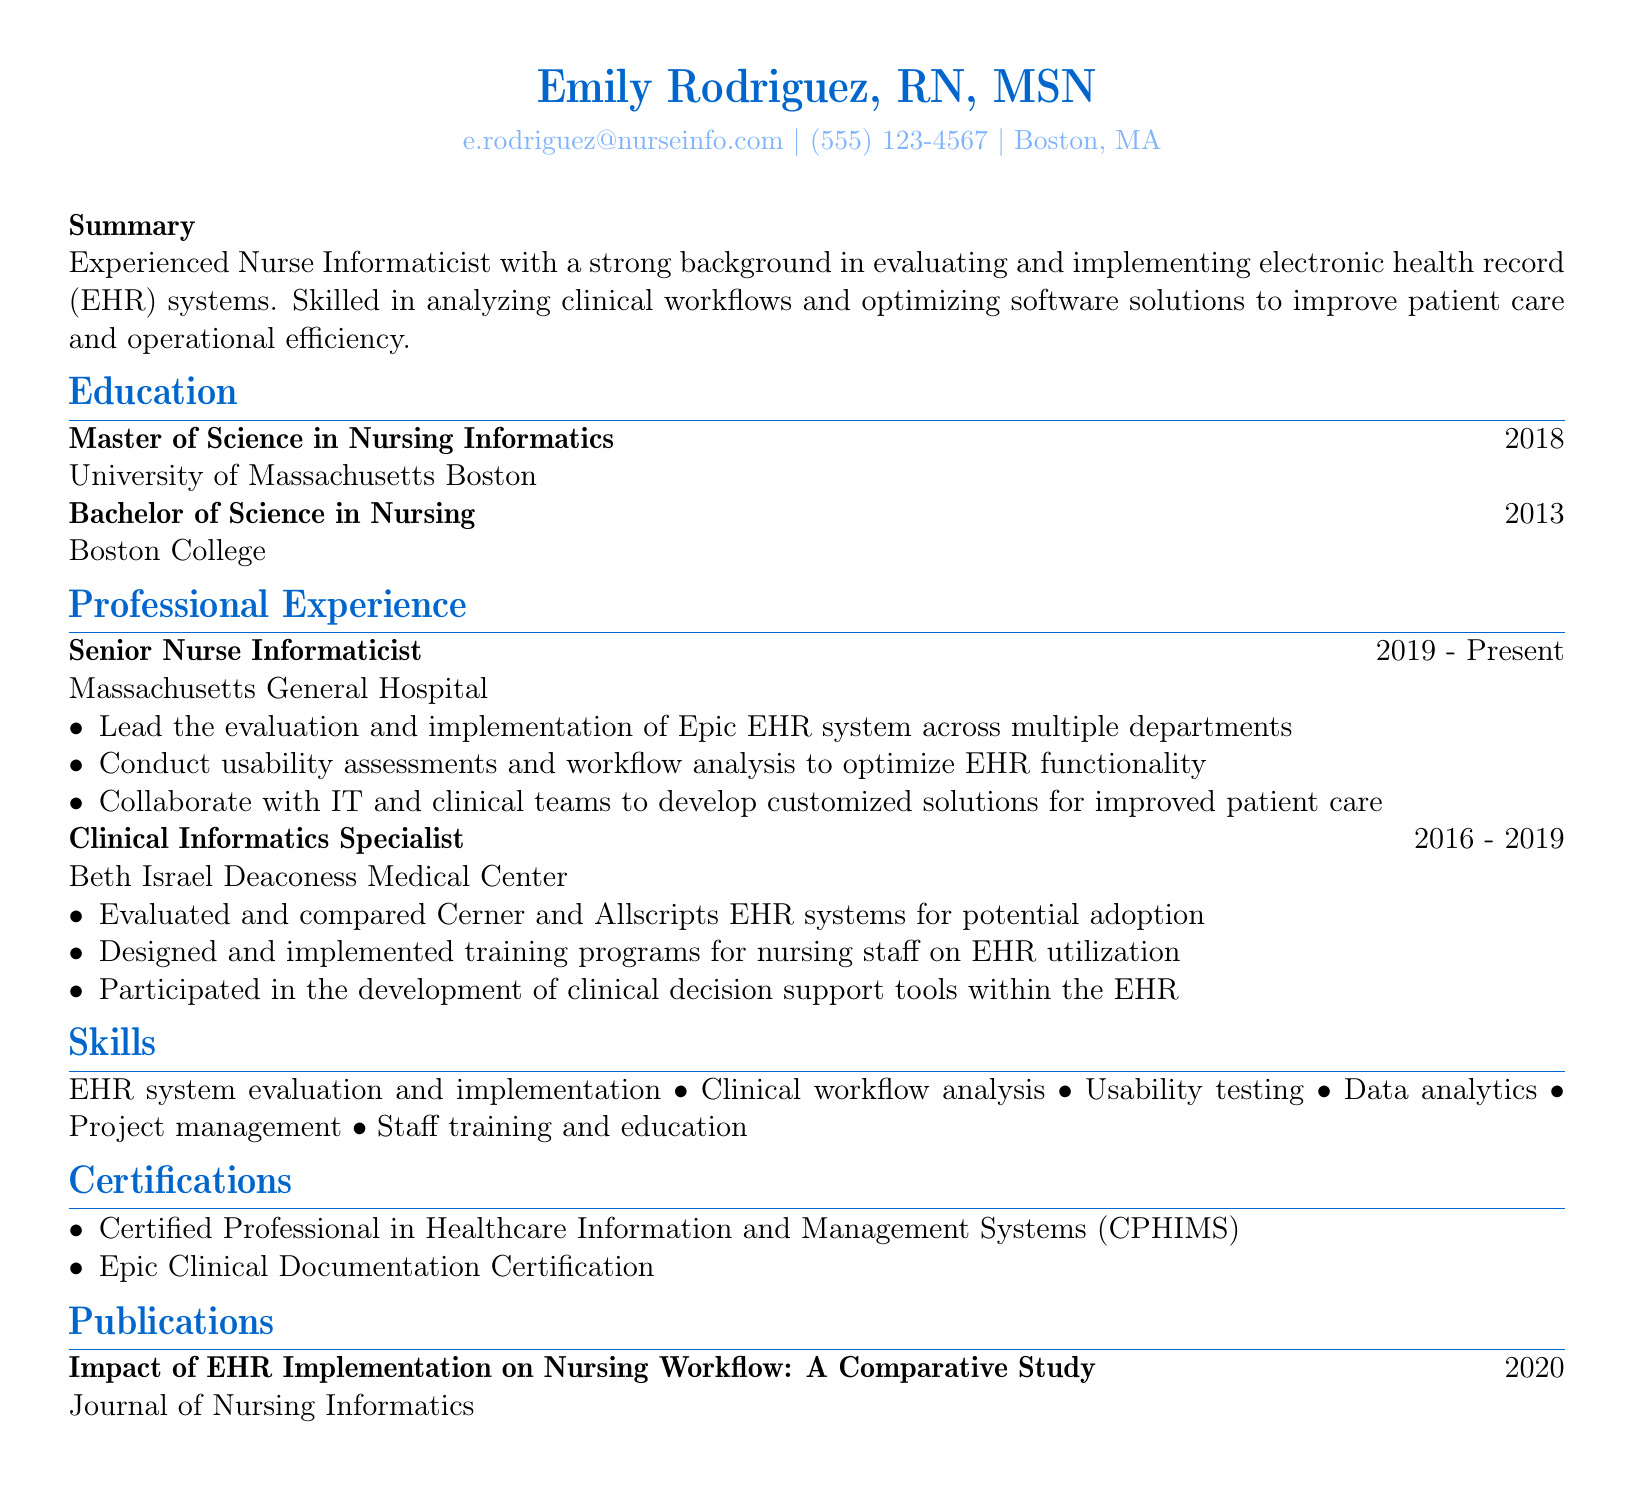what is the name of the Nurse Informaticist? The name is listed prominently at the top of the document.
Answer: Emily Rodriguez, RN, MSN what is the current position held by Emily Rodriguez? The document lists her current job title in the Professional Experience section.
Answer: Senior Nurse Informaticist which year did Emily obtain her Master of Science in Nursing Informatics? The year is shown in the Education section next to her degree.
Answer: 2018 how many years of experience does Emily have at Massachusetts General Hospital? Calculating the duration from 2019 to the present gives the total experience at that organization.
Answer: 4 years what certification does Emily hold related to healthcare information systems? This information is mentioned in the Certifications section.
Answer: CPHIMS what type of analysis does Emily conduct for optimizing EHR functionality? The specific type of analysis is mentioned in her responsibilities at Massachusetts General Hospital.
Answer: Usability assessments which EHR systems did Emily evaluate at Beth Israel Deaconess Medical Center? The names of the EHR systems are listed under her responsibilities.
Answer: Cerner and Allscripts how many publications does Emily have listed in her CV? The number of publications can be determined from the Publications section.
Answer: 1 what is the main focus of Emily's CV? The focus is summarized in the Summary section of the document.
Answer: Evaluating and implementing electronic health record systems 